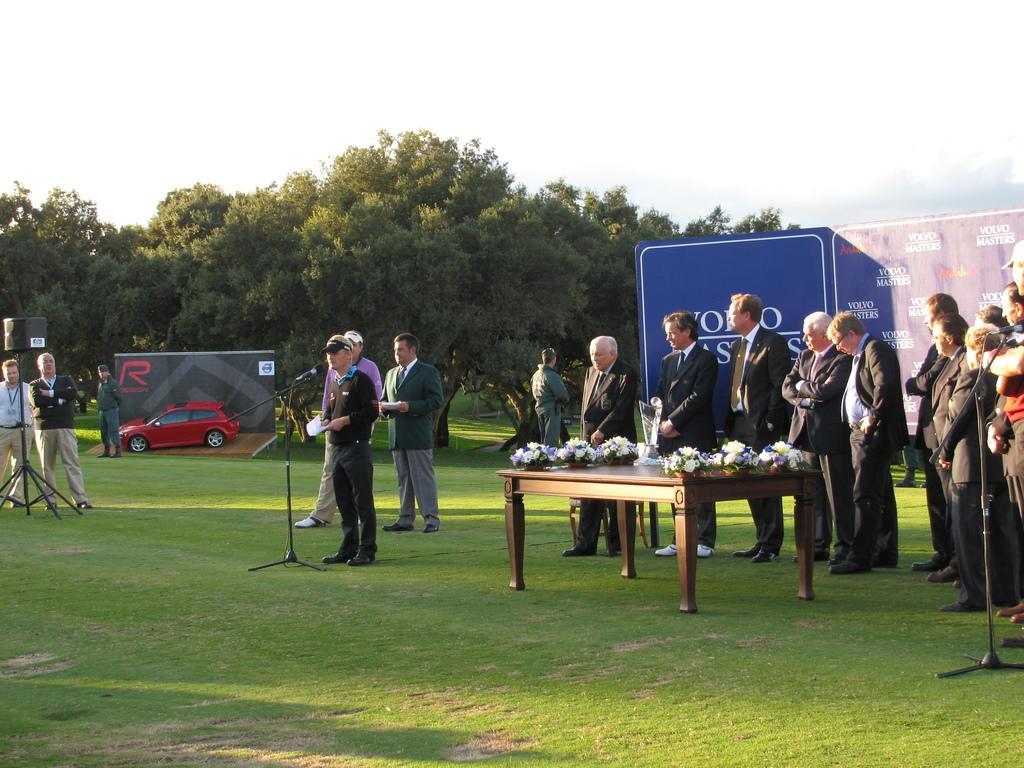How would you summarize this image in a sentence or two? There are group of people in the image who are standing. On left side there is a man who is wearing his hat and holding paper standing in front of a microphone. In middle there is a table on table we can see flowers,plants,flower pot and a glass in background there are hoardings,trees and sky on top. 